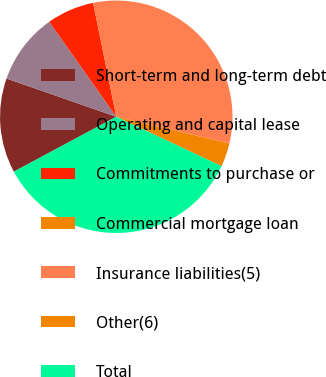Convert chart. <chart><loc_0><loc_0><loc_500><loc_500><pie_chart><fcel>Short-term and long-term debt<fcel>Operating and capital lease<fcel>Commitments to purchase or<fcel>Commercial mortgage loan<fcel>Insurance liabilities(5)<fcel>Other(6)<fcel>Total<nl><fcel>13.17%<fcel>9.88%<fcel>6.59%<fcel>0.0%<fcel>31.89%<fcel>3.29%<fcel>35.18%<nl></chart> 